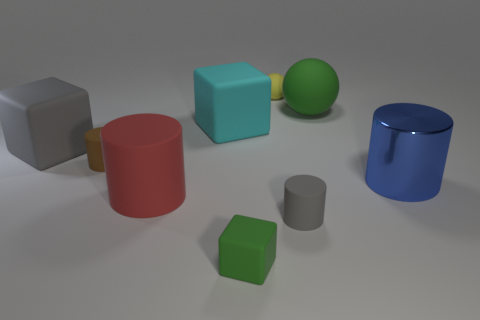Subtract all small cubes. How many cubes are left? 2 Subtract all blue cylinders. How many cylinders are left? 3 Add 1 gray matte cylinders. How many objects exist? 10 Subtract all yellow cubes. Subtract all green cylinders. How many cubes are left? 3 Subtract all spheres. How many objects are left? 7 Add 5 large matte cylinders. How many large matte cylinders are left? 6 Add 5 large blue metallic blocks. How many large blue metallic blocks exist? 5 Subtract 0 purple cylinders. How many objects are left? 9 Subtract all small spheres. Subtract all tiny green objects. How many objects are left? 7 